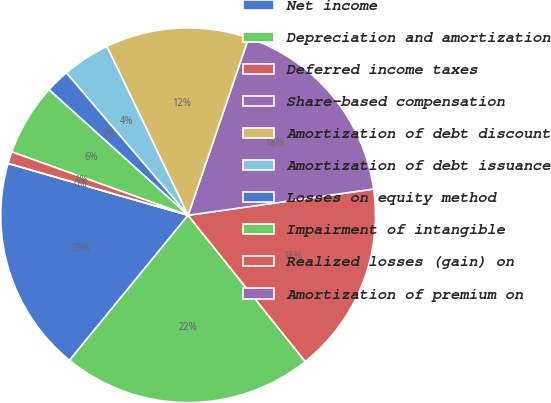Convert chart. <chart><loc_0><loc_0><loc_500><loc_500><pie_chart><fcel>Net income<fcel>Depreciation and amortization<fcel>Deferred income taxes<fcel>Share-based compensation<fcel>Amortization of debt discount<fcel>Amortization of debt issuance<fcel>Losses on equity method<fcel>Impairment of intangible<fcel>Realized losses (gain) on<fcel>Amortization of premium on<nl><fcel>18.56%<fcel>21.65%<fcel>16.49%<fcel>17.53%<fcel>12.37%<fcel>4.12%<fcel>2.06%<fcel>6.19%<fcel>1.03%<fcel>0.0%<nl></chart> 